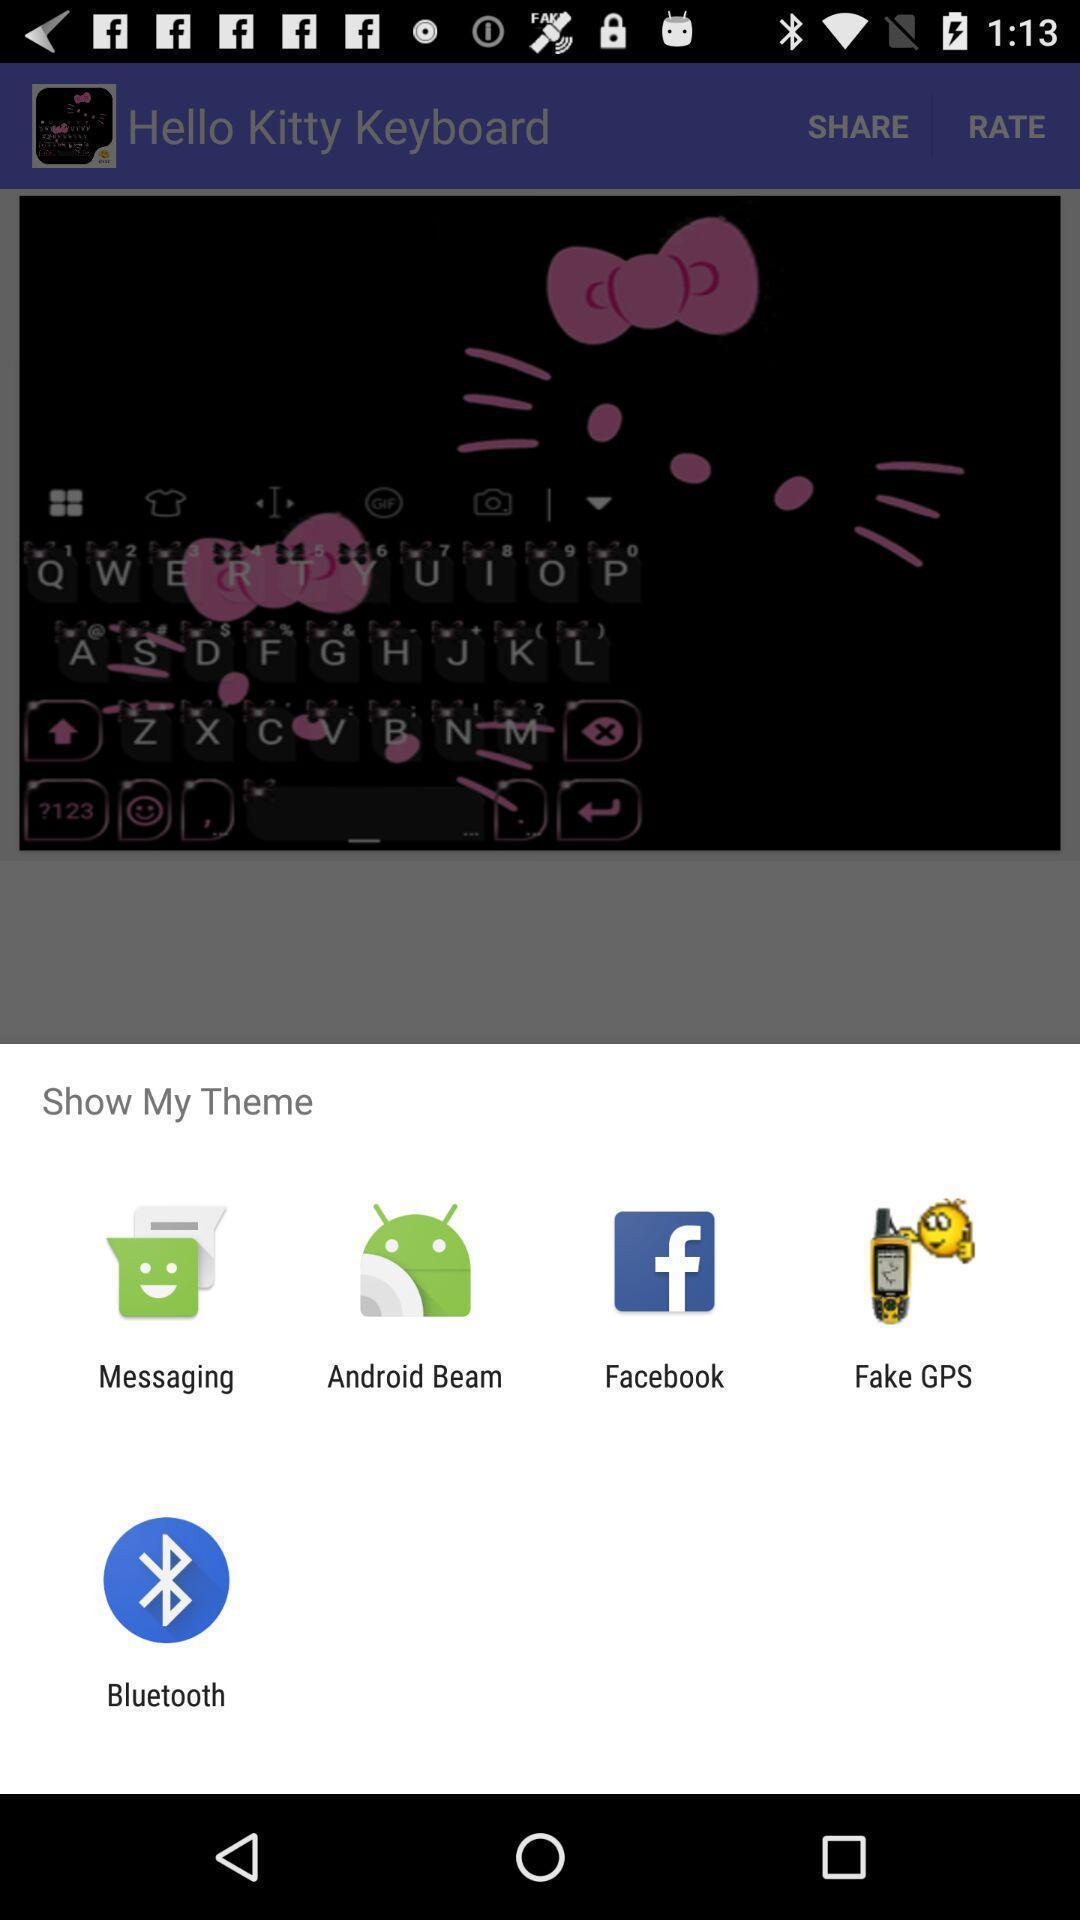Give me a summary of this screen capture. Pop-up showing different show my theme options. 